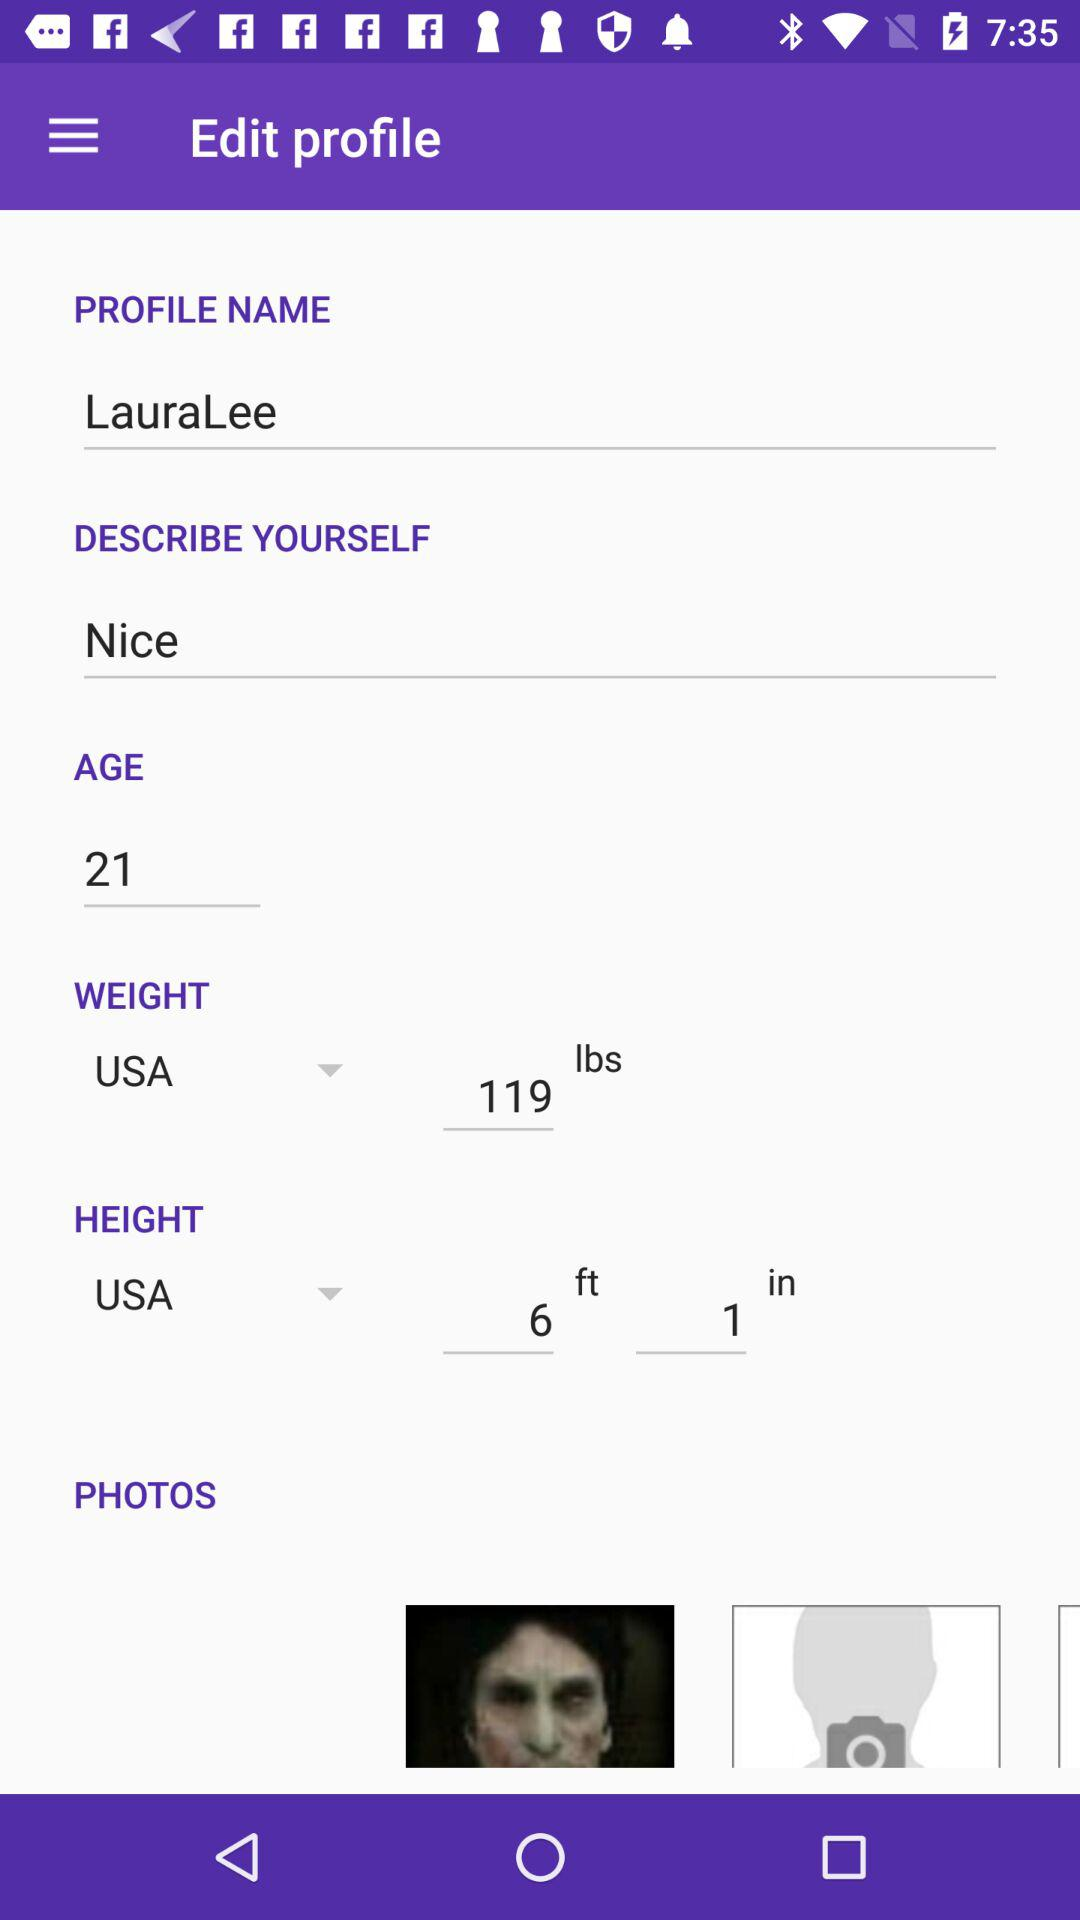What is the given height? The given height is 6 feet and 1 inch. 